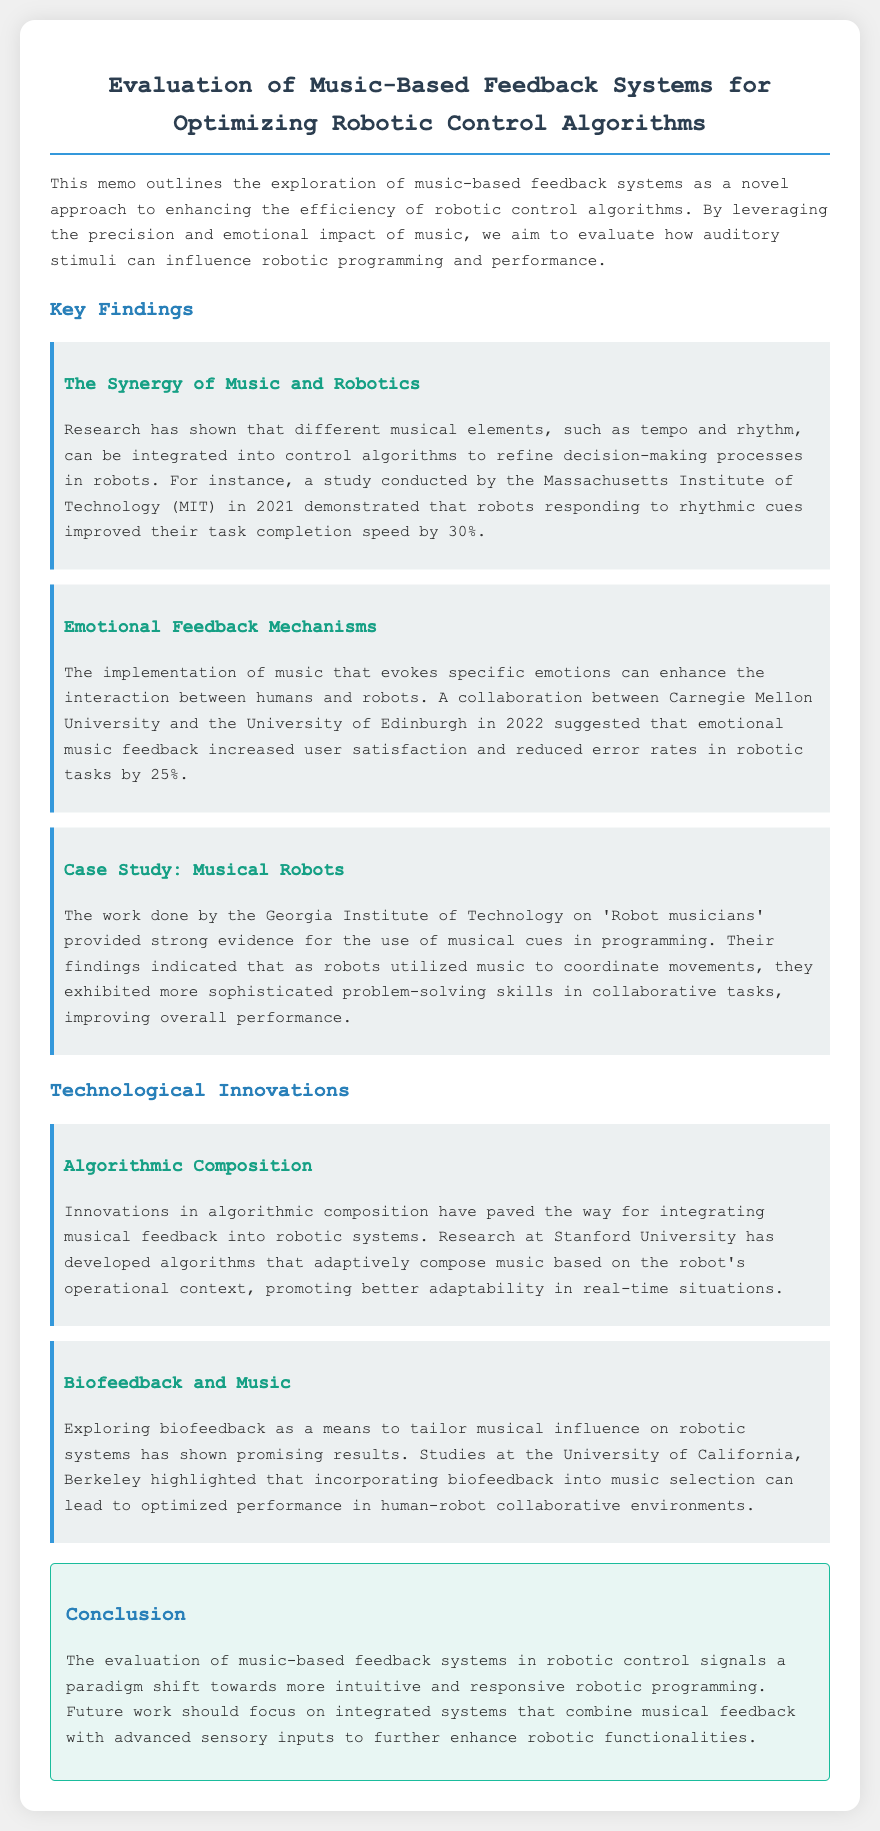What year did MIT demonstrate improved task completion speed? The document states that MIT conducted a study in 2021, which demonstrated the improvement.
Answer: 2021 What is the percentage improvement in task completion speed mentioned in the memo? The memo indicates that robots improved their task completion speed by 30%.
Answer: 30% Which universities collaborated in 2022 for emotional music feedback? The collaboration mentioned in the memo involved Carnegie Mellon University and the University of Edinburgh.
Answer: Carnegie Mellon University and the University of Edinburgh What did the Georgia Institute of Technology's findings about 'Robot musicians' indicate? The findings indicated that robots improved overall performance by utilizing music to coordinate movements.
Answer: Improved overall performance What innovative approach was developed at Stanford University for robotic systems? The document describes that Stanford University developed algorithms for adaptive music composition based on the robot's operational context.
Answer: Algorithmic composition What field of study did the University of California, Berkeley explore regarding music? The document discusses their exploration of biofeedback as a means to tailor musical influence on robotic systems.
Answer: Biofeedback What is the main focus for future work as mentioned in the conclusion? The conclusion states that future work should focus on integrated systems combining musical feedback with advanced sensory inputs.
Answer: Integrated systems How much did user satisfaction increase due to emotional music feedback? The memo suggests that emotional music feedback increased user satisfaction and reduced error rates by 25%.
Answer: 25% What type of feedback system is discussed in this memo? The memo outlines the evaluation of music-based feedback systems.
Answer: Music-based feedback systems 